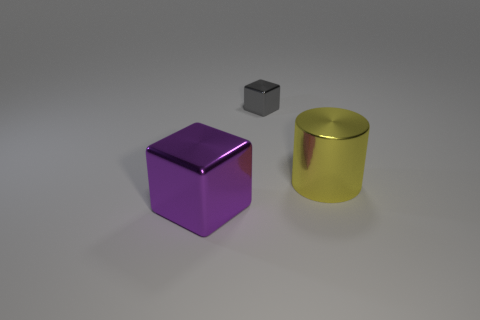There is a purple object that is the same material as the tiny gray thing; what is its size?
Make the answer very short. Large. Does the gray cube have the same material as the cylinder?
Offer a very short reply. Yes. How many other objects are the same material as the tiny gray block?
Keep it short and to the point. 2. How many metal things are to the left of the metal cylinder and in front of the small object?
Provide a succinct answer. 1. What color is the cylinder?
Offer a very short reply. Yellow. What is the material of the big purple thing that is the same shape as the gray metallic thing?
Your response must be concise. Metal. Are there any other things that are made of the same material as the large purple cube?
Keep it short and to the point. Yes. Is the shiny cylinder the same color as the tiny metal object?
Make the answer very short. No. There is a big metallic object to the right of the cube to the left of the tiny gray thing; what shape is it?
Your answer should be compact. Cylinder. There is a gray object that is made of the same material as the large purple cube; what shape is it?
Provide a short and direct response. Cube. 